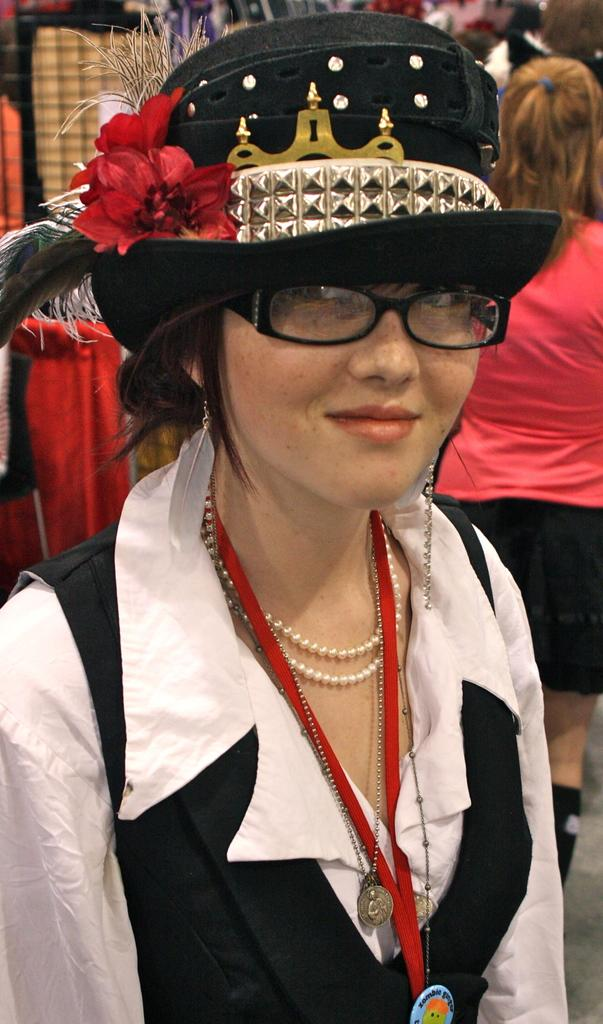Who is the main subject in the image? There is a woman in the center of the image. What is the woman wearing on her head? The woman is wearing a black hat. What is the woman's facial expression in the image? The woman is smiling. Can you describe the other person in the image? There is another woman in the background. What type of clothing can be seen in the image? Clothes are visible in the image. What type of bushes can be seen growing on the woman's hat in the image? There are no bushes visible on the woman's hat in the image. How many snails can be seen crawling on the woman's clothes in the image? There are no snails visible on the woman's clothes in the image. 